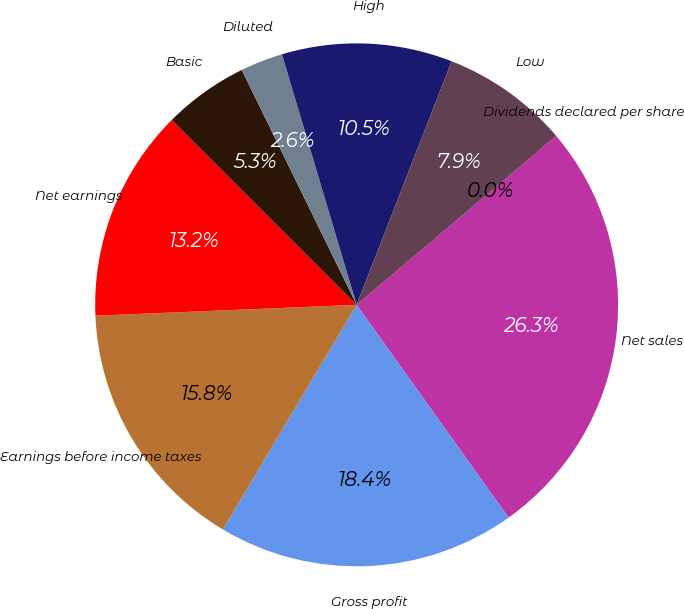Convert chart to OTSL. <chart><loc_0><loc_0><loc_500><loc_500><pie_chart><fcel>Net sales<fcel>Gross profit<fcel>Earnings before income taxes<fcel>Net earnings<fcel>Basic<fcel>Diluted<fcel>High<fcel>Low<fcel>Dividends declared per share<nl><fcel>26.31%<fcel>18.42%<fcel>15.79%<fcel>13.16%<fcel>5.26%<fcel>2.63%<fcel>10.53%<fcel>7.9%<fcel>0.0%<nl></chart> 